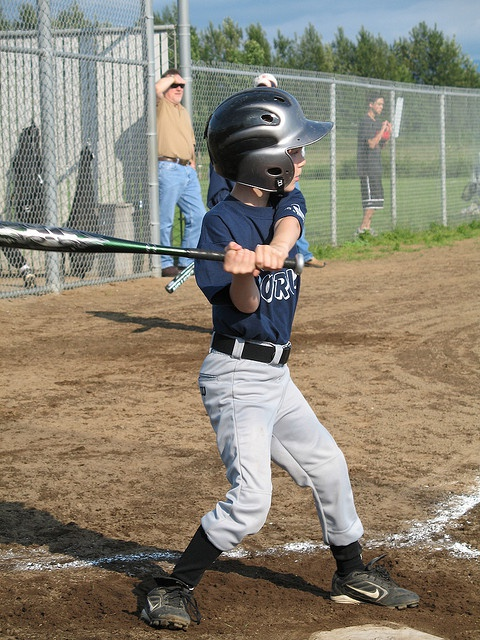Describe the objects in this image and their specific colors. I can see people in gray, lightgray, black, and darkgray tones, people in gray, lightblue, and tan tones, baseball bat in gray, black, white, and darkgray tones, people in gray, darkgray, and tan tones, and people in gray, white, darkgray, and black tones in this image. 